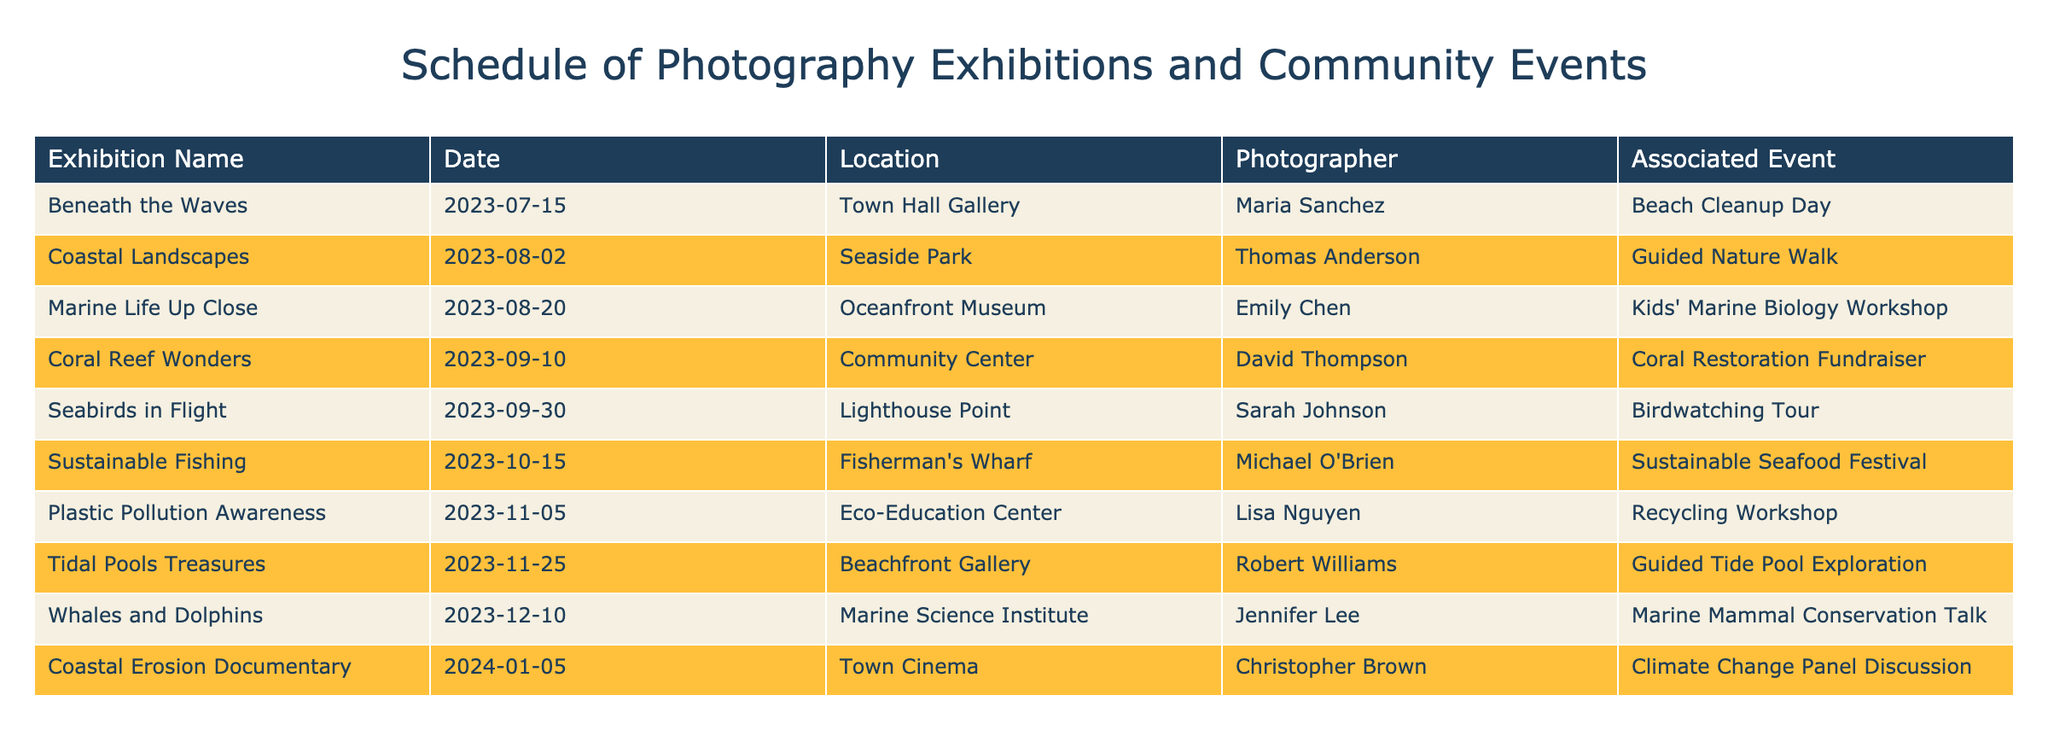What is the name of the exhibition taking place on August 2, 2023? The table lists the exhibitions with their corresponding dates. Looking for the date August 2, 2023, we find "Coastal Landscapes" listed under that date.
Answer: Coastal Landscapes How many exhibitions are scheduled in September 2023? From the table, the exhibitions scheduled in September are "Coral Reef Wonders" on the 10th and "Seabirds in Flight" on the 30th. Counting these gives us a total of 2 exhibitions.
Answer: 2 Is there an associated event for the exhibition "Marine Life Up Close"? The table indicates that "Marine Life Up Close" is linked with the "Kids' Marine Biology Workshop," confirming that there is an associated event.
Answer: Yes What is the location of the "Plastic Pollution Awareness" exhibition? This exhibition is listed in the table, and its location is the "Eco-Education Center," as stated in the corresponding row.
Answer: Eco-Education Center Which photographer has an exhibition on the same date as the "Sustainable Fishing" exhibition? The "Sustainable Fishing" exhibition is scheduled for October 15, 2023. Checking the table, no other exhibitions share this date, indicating that it is the only one scheduled for that day.
Answer: None What is the total number of exhibitions scheduled for 2023? There are ten exhibitions listed in the table, occurring between July and December 2023. Thus, the total number of exhibitions for that year is 10.
Answer: 10 Which exhibition features a guided activity related to tide pools? The table shows that the exhibition "Tidal Pools Treasures" is associated with the "Guided Tide Pool Exploration," indicating that it features a related guided activity.
Answer: Tidal Pools Treasures Are there more exhibitions in November than in August? In November, there are two exhibitions ("Plastic Pollution Awareness" and "Tidal Pools Treasures"), whereas August has three exhibitions ("Coastal Landscapes", "Marine Life Up Close"). Comparing these totals, November has 2 and August has 3, showing that there are fewer in November.
Answer: No What is the combined number of exhibitions taking place in October and November? The exhibitions in October include "Sustainable Fishing" (1), and in November, there are two exhibitions ("Plastic Pollution Awareness", "Tidal Pools Treasures"). Adding these together gives a total of 3 exhibitions for those two months.
Answer: 3 